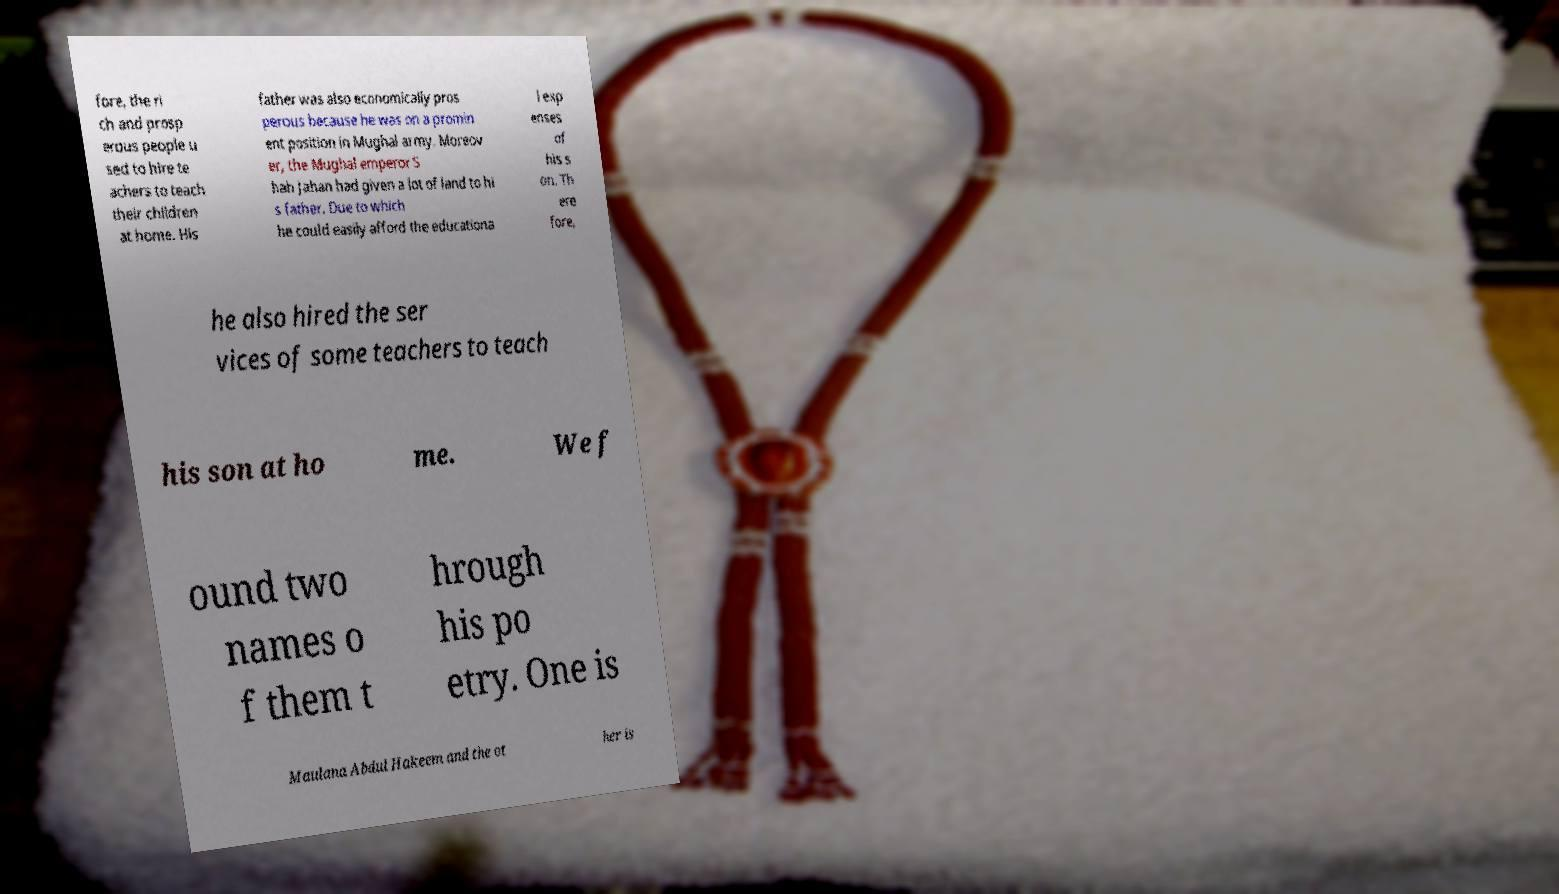What messages or text are displayed in this image? I need them in a readable, typed format. fore, the ri ch and prosp erous people u sed to hire te achers to teach their children at home. His father was also economically pros perous because he was on a promin ent position in Mughal army. Moreov er, the Mughal emperor S hah Jahan had given a lot of land to hi s father. Due to which he could easily afford the educationa l exp enses of his s on. Th ere fore, he also hired the ser vices of some teachers to teach his son at ho me. We f ound two names o f them t hrough his po etry. One is Maulana Abdul Hakeem and the ot her is 